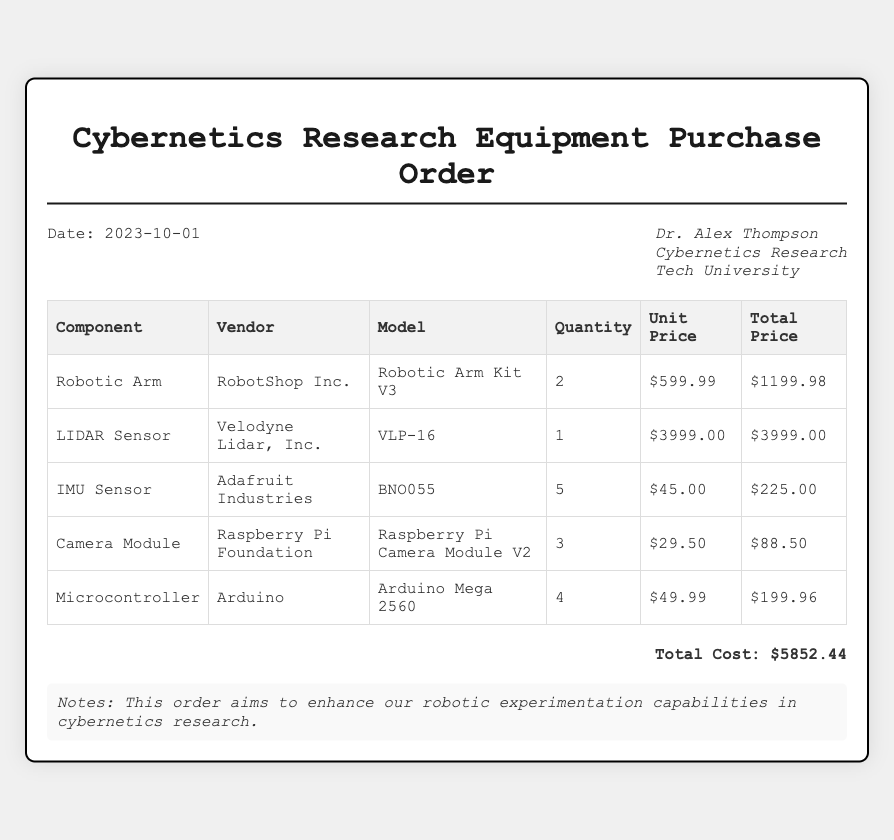What is the date of the purchase order? The date of the purchase order is stated at the top of the document.
Answer: 2023-10-01 Who is the researcher making the order? The name of the researcher is indicated in the header of the document.
Answer: Dr. Alex Thompson How many LIDAR Sensors are being purchased? The quantity of LIDAR Sensors is found in the respective row of the table.
Answer: 1 What is the total cost of the order? The total cost is calculated and displayed at the bottom of the document.
Answer: $5852.44 Which vendor supplies the Robotic Arm? The vendor for the Robotic Arm can be found in the table alongside the component name.
Answer: RobotShop Inc How many IMU Sensors are included in this order? The number of IMU Sensors is specified in the relevant row in the table.
Answer: 5 Which component has the highest unit price? The highest unit price can be determined by comparing the unit prices listed in the table.
Answer: LIDAR Sensor What is the model of the camera module? The model of the camera module is indicated in the table next to its name.
Answer: Raspberry Pi Camera Module V2 How many total components are listed in the order? The total number of different components can be counted from the number of rows in the table.
Answer: 5 